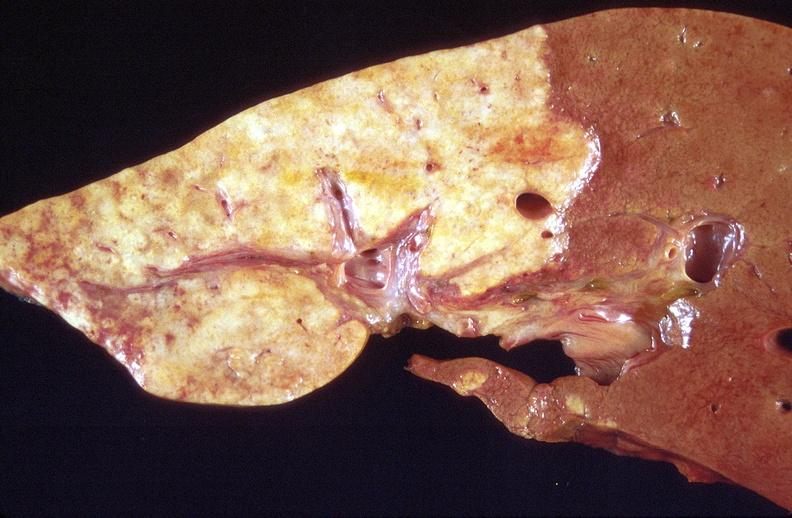what is present?
Answer the question using a single word or phrase. Liver 